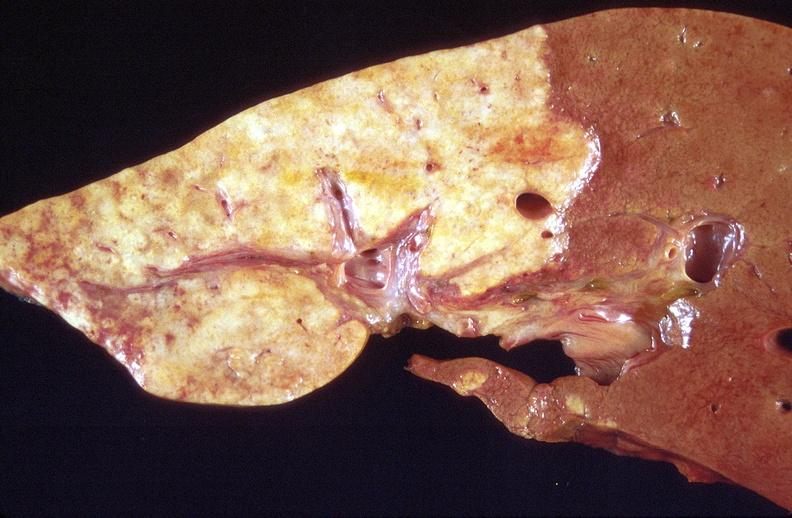what is present?
Answer the question using a single word or phrase. Liver 